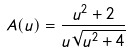<formula> <loc_0><loc_0><loc_500><loc_500>A ( u ) = \frac { u ^ { 2 } + 2 } { u \sqrt { u ^ { 2 } + 4 } }</formula> 